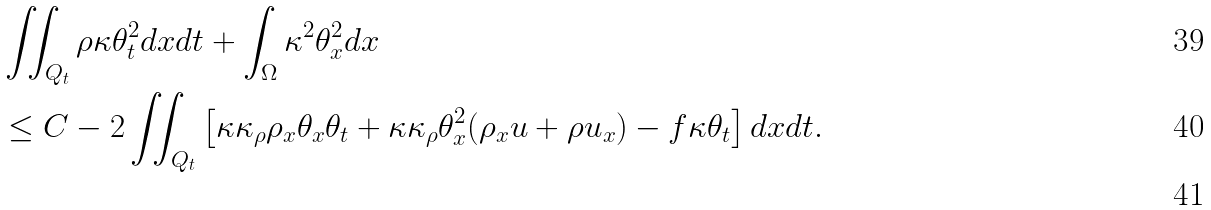<formula> <loc_0><loc_0><loc_500><loc_500>& \iint _ { Q _ { t } } \rho \kappa \theta _ { t } ^ { 2 } d x d t + \int _ { \Omega } \kappa ^ { 2 } \theta _ { x } ^ { 2 } d x \\ & \leq C - 2 \iint _ { Q _ { t } } \left [ \kappa \kappa _ { \rho } \rho _ { x } \theta _ { x } \theta _ { t } + \kappa \kappa _ { \rho } \theta _ { x } ^ { 2 } ( \rho _ { x } u + \rho u _ { x } ) - f \kappa \theta _ { t } \right ] d x d t . \\</formula> 